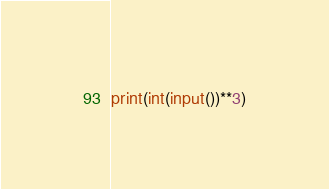Convert code to text. <code><loc_0><loc_0><loc_500><loc_500><_Python_>print(int(input())**3)</code> 